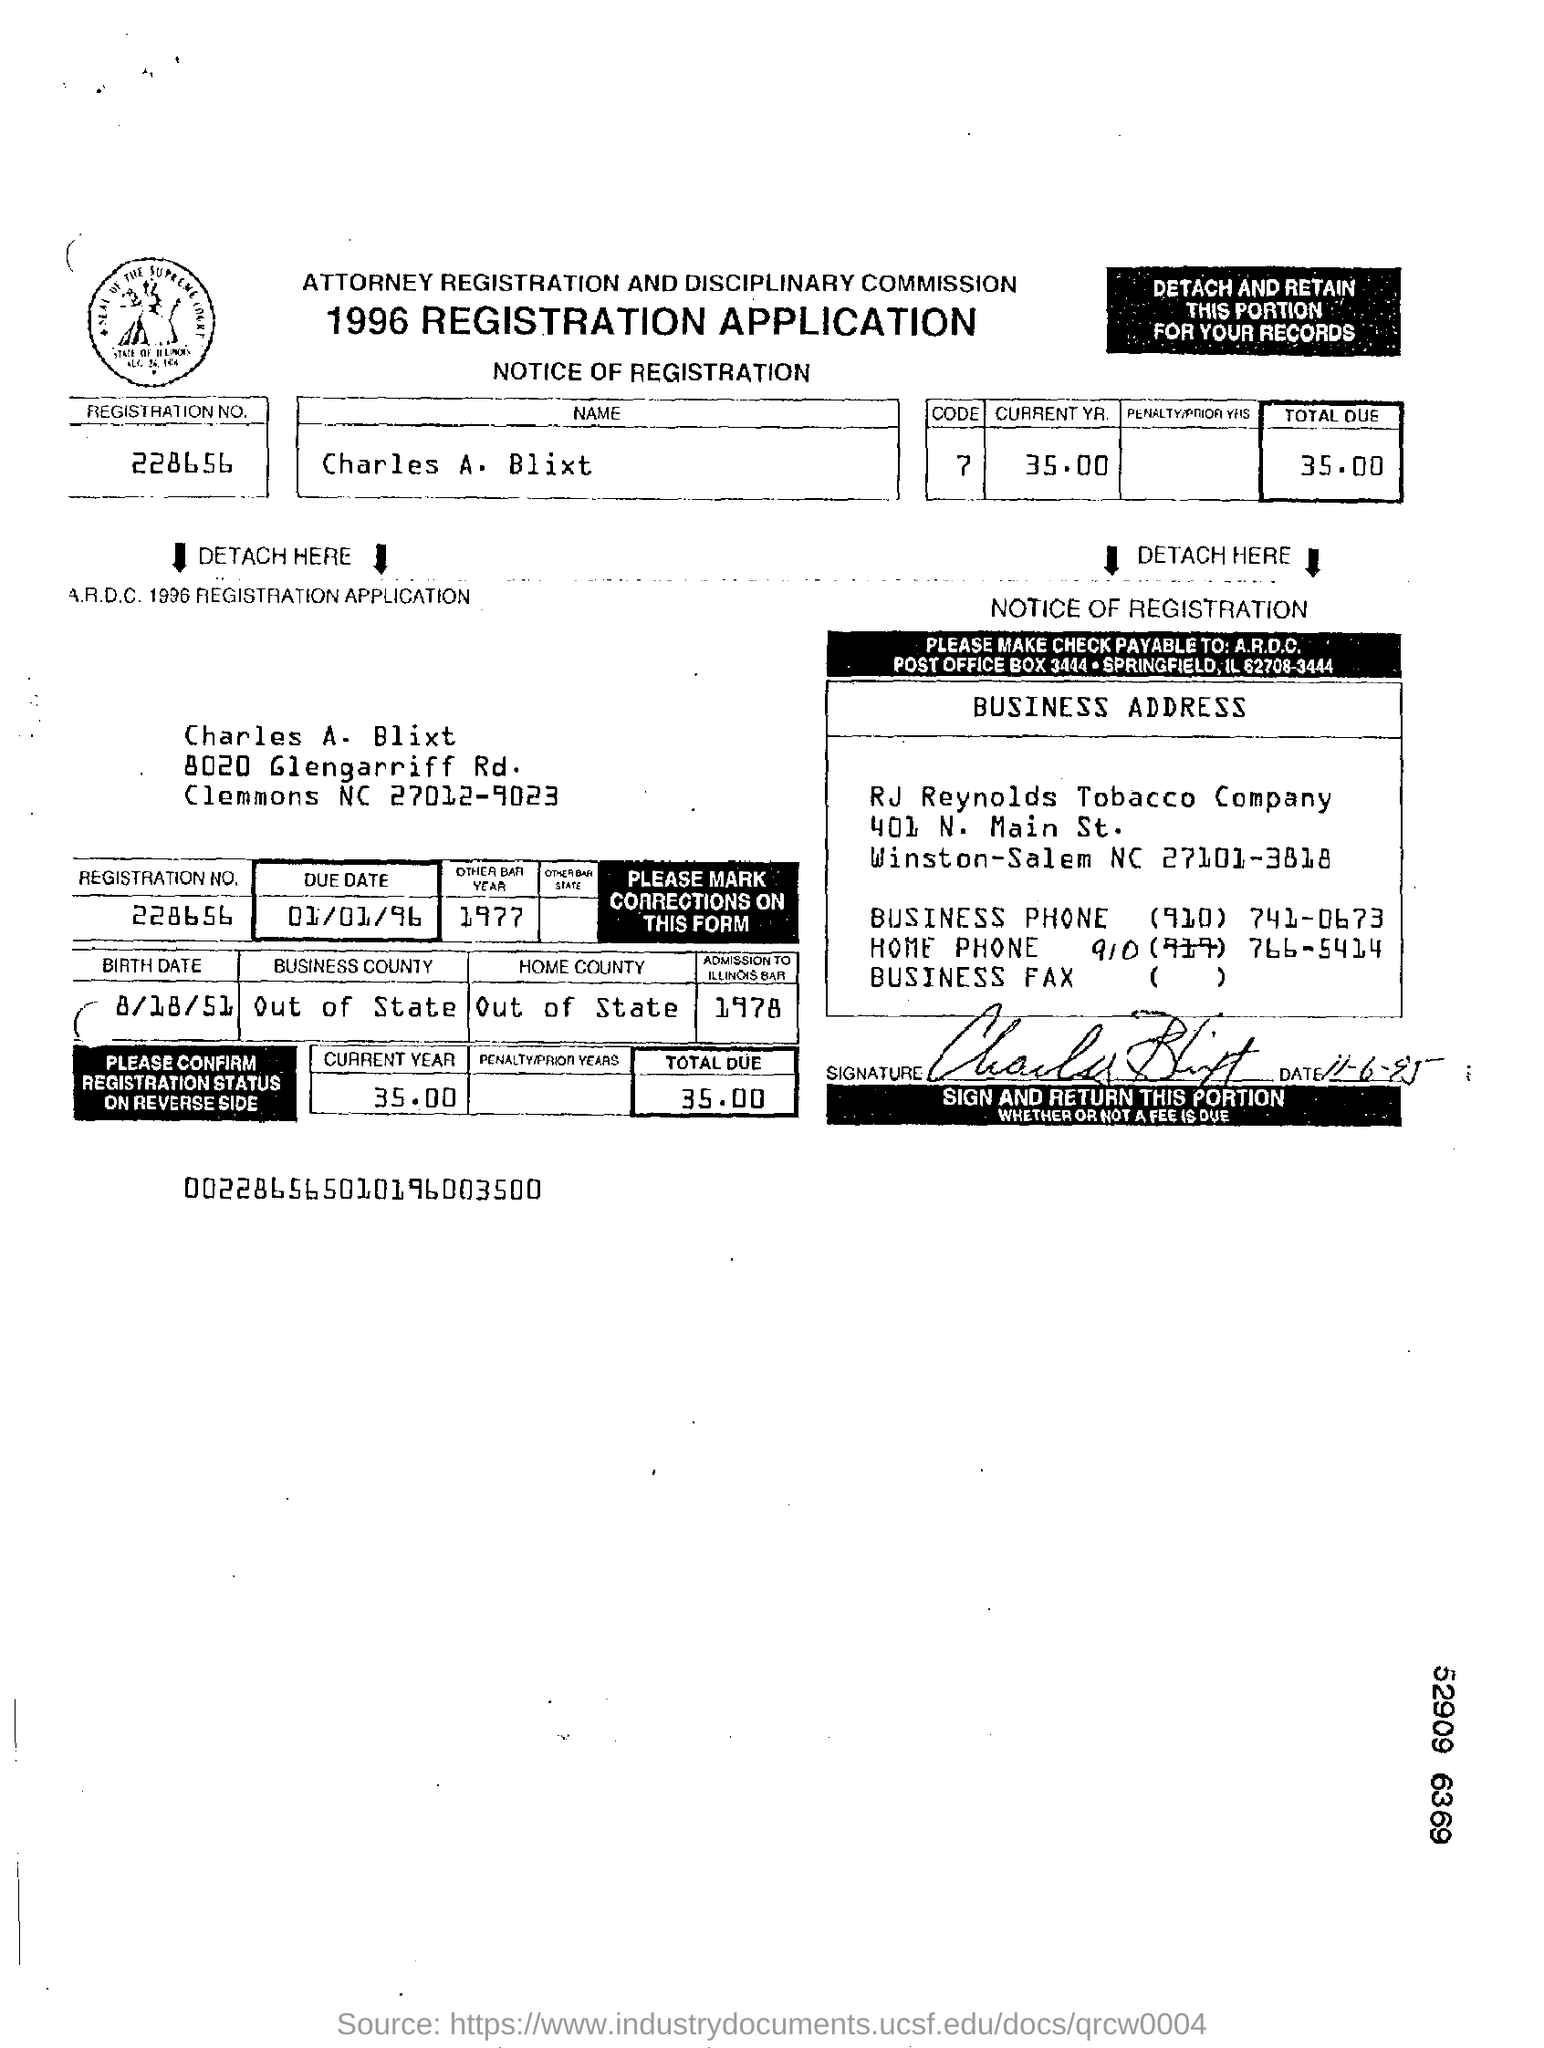List a handful of essential elements in this visual. The total amount due, as stated in the application, is 35. The applicant's name is Charles A. Blixt. The application indicates a due date of January 1, 1996. Charles A. Blixt was born on August 18, 1951. The registration number provided in the application is 228656... 